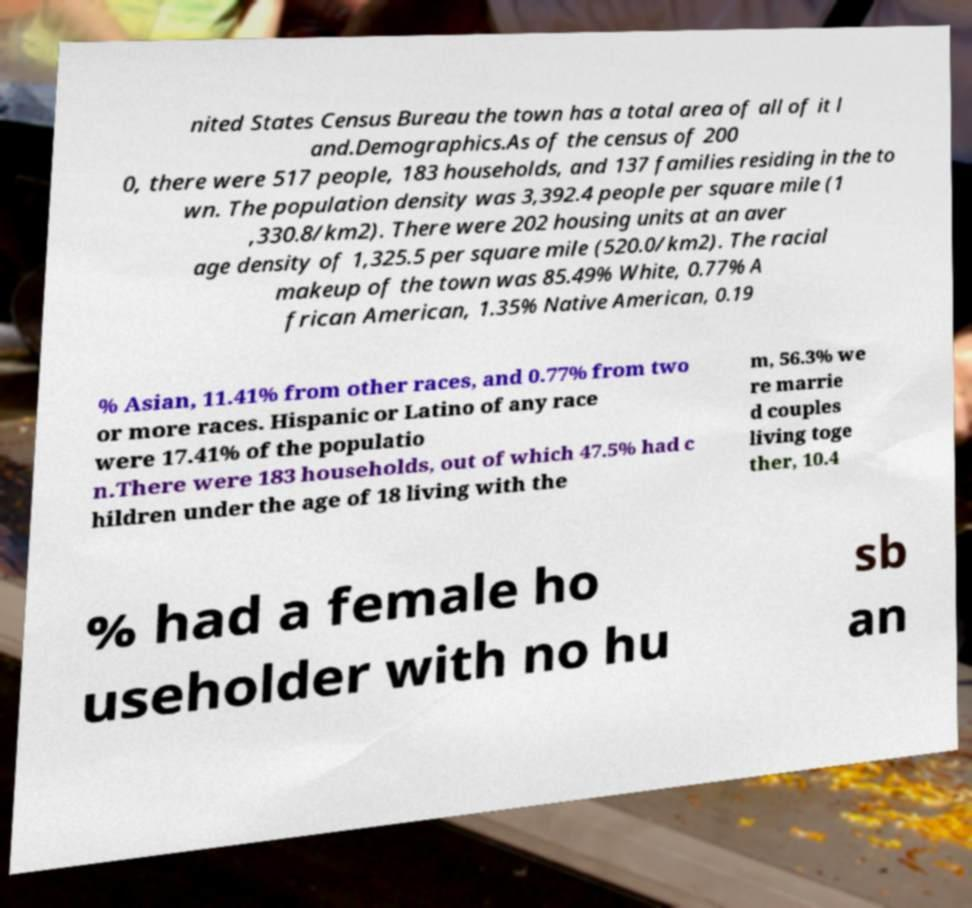What messages or text are displayed in this image? I need them in a readable, typed format. nited States Census Bureau the town has a total area of all of it l and.Demographics.As of the census of 200 0, there were 517 people, 183 households, and 137 families residing in the to wn. The population density was 3,392.4 people per square mile (1 ,330.8/km2). There were 202 housing units at an aver age density of 1,325.5 per square mile (520.0/km2). The racial makeup of the town was 85.49% White, 0.77% A frican American, 1.35% Native American, 0.19 % Asian, 11.41% from other races, and 0.77% from two or more races. Hispanic or Latino of any race were 17.41% of the populatio n.There were 183 households, out of which 47.5% had c hildren under the age of 18 living with the m, 56.3% we re marrie d couples living toge ther, 10.4 % had a female ho useholder with no hu sb an 